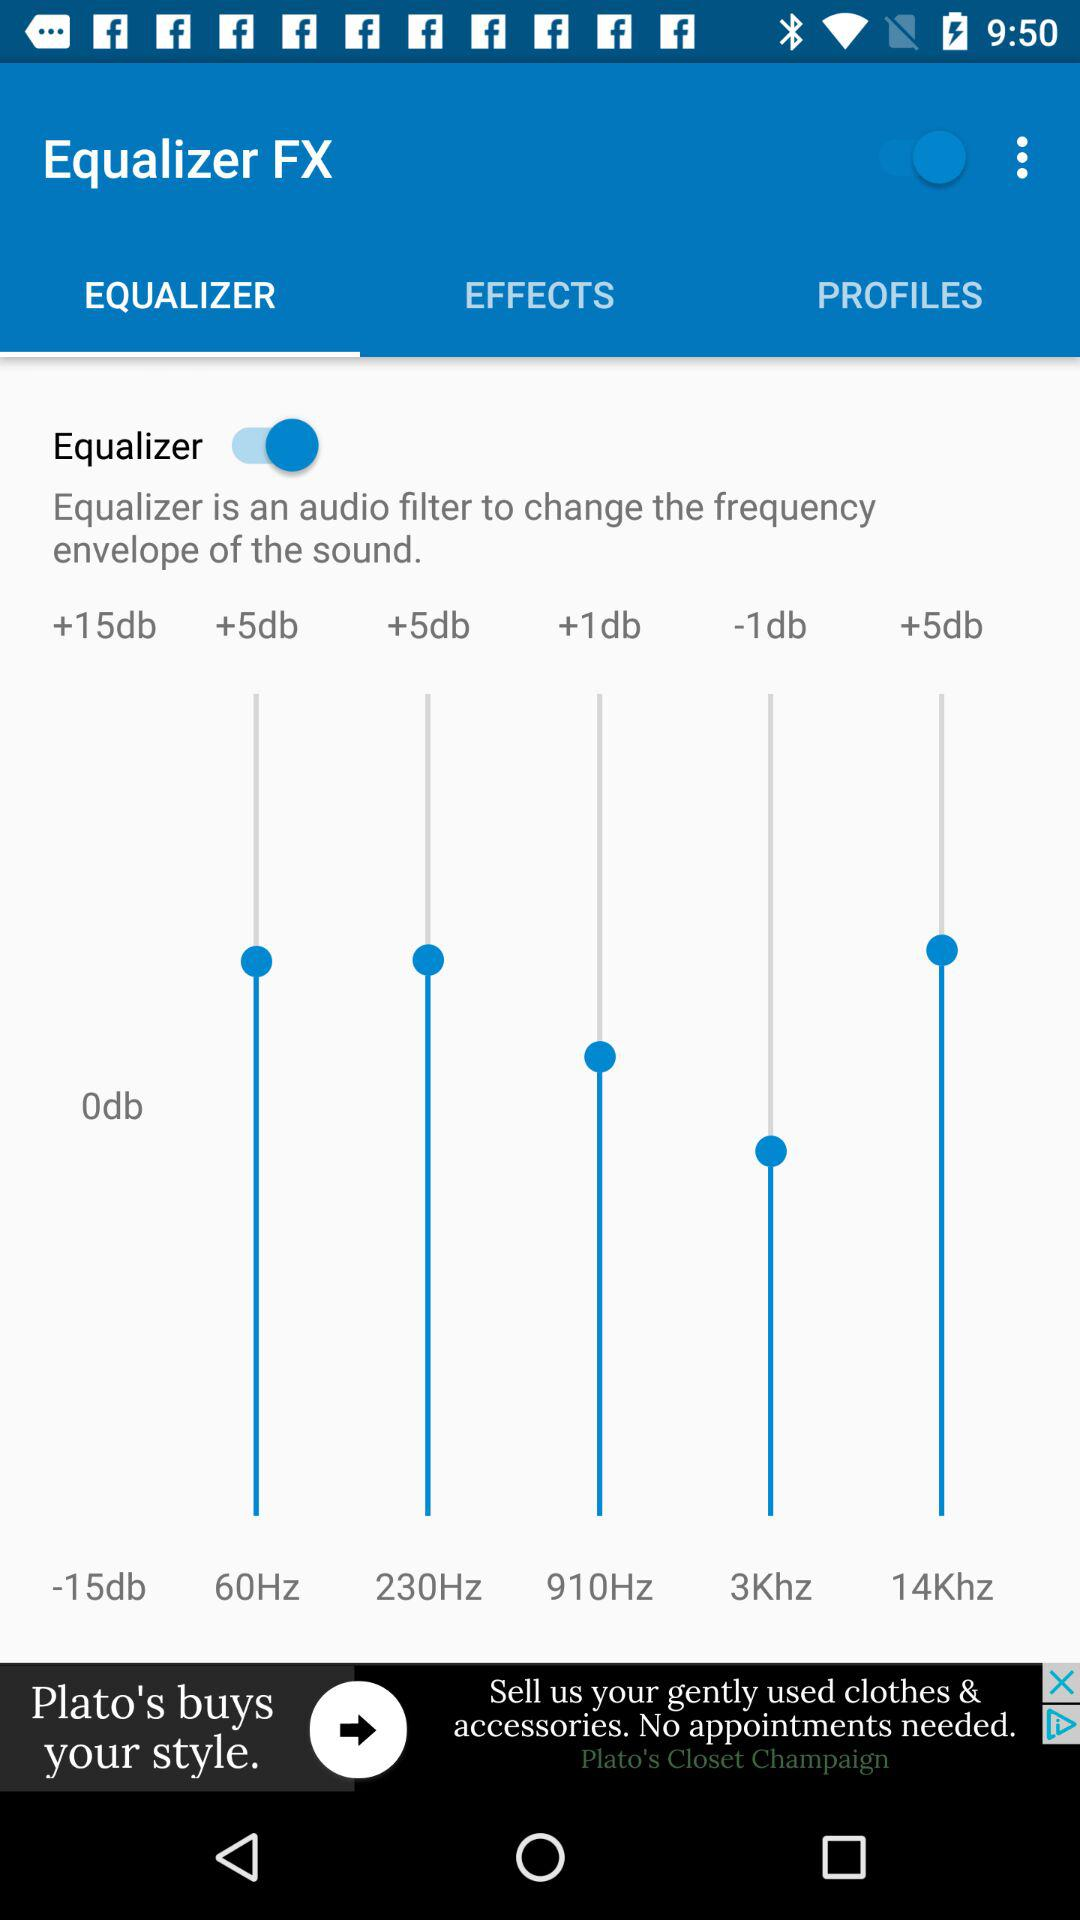What version of "Equalizer FX" is being used?
When the provided information is insufficient, respond with <no answer>. <no answer> 